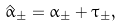Convert formula to latex. <formula><loc_0><loc_0><loc_500><loc_500>\hat { \alpha } _ { \pm } = \alpha _ { \pm } + \tau _ { \pm } ,</formula> 